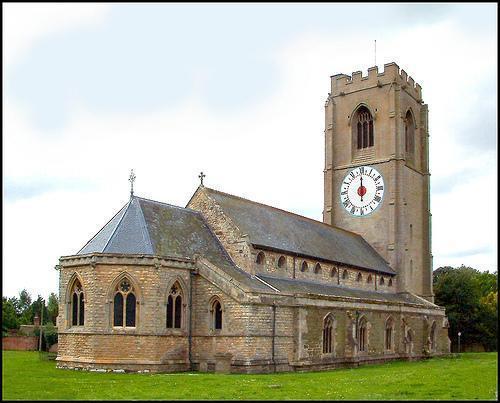How many towers does the building have?
Give a very brief answer. 1. How many cross are on the roof?
Give a very brief answer. 2. How many windows are in the circular front?
Give a very brief answer. 3. 